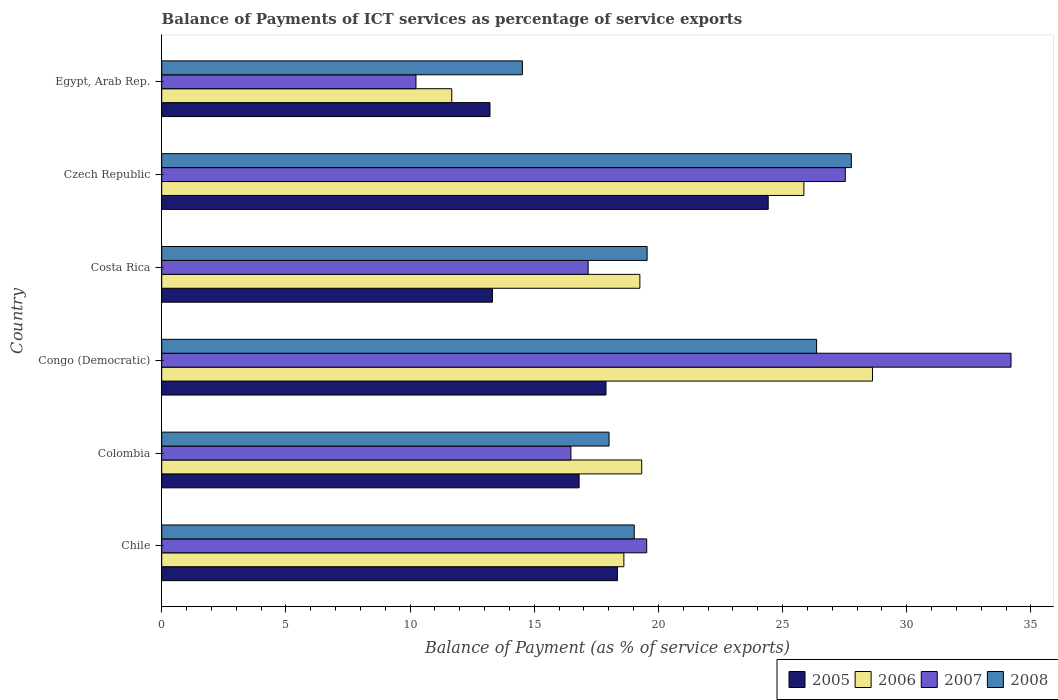How many groups of bars are there?
Keep it short and to the point. 6. Are the number of bars on each tick of the Y-axis equal?
Ensure brevity in your answer.  Yes. How many bars are there on the 6th tick from the bottom?
Provide a succinct answer. 4. What is the balance of payments of ICT services in 2007 in Egypt, Arab Rep.?
Your response must be concise. 10.24. Across all countries, what is the maximum balance of payments of ICT services in 2005?
Ensure brevity in your answer.  24.42. Across all countries, what is the minimum balance of payments of ICT services in 2006?
Offer a terse response. 11.68. In which country was the balance of payments of ICT services in 2006 maximum?
Offer a terse response. Congo (Democratic). In which country was the balance of payments of ICT services in 2007 minimum?
Your answer should be very brief. Egypt, Arab Rep. What is the total balance of payments of ICT services in 2007 in the graph?
Offer a very short reply. 125.14. What is the difference between the balance of payments of ICT services in 2006 in Congo (Democratic) and that in Egypt, Arab Rep.?
Your answer should be compact. 16.94. What is the difference between the balance of payments of ICT services in 2005 in Colombia and the balance of payments of ICT services in 2007 in Costa Rica?
Provide a succinct answer. -0.36. What is the average balance of payments of ICT services in 2006 per country?
Your answer should be very brief. 20.56. What is the difference between the balance of payments of ICT services in 2007 and balance of payments of ICT services in 2006 in Chile?
Provide a succinct answer. 0.92. In how many countries, is the balance of payments of ICT services in 2008 greater than 18 %?
Ensure brevity in your answer.  5. What is the ratio of the balance of payments of ICT services in 2008 in Chile to that in Congo (Democratic)?
Offer a terse response. 0.72. Is the difference between the balance of payments of ICT services in 2007 in Colombia and Egypt, Arab Rep. greater than the difference between the balance of payments of ICT services in 2006 in Colombia and Egypt, Arab Rep.?
Provide a short and direct response. No. What is the difference between the highest and the second highest balance of payments of ICT services in 2007?
Your response must be concise. 6.67. What is the difference between the highest and the lowest balance of payments of ICT services in 2006?
Your answer should be very brief. 16.94. In how many countries, is the balance of payments of ICT services in 2008 greater than the average balance of payments of ICT services in 2008 taken over all countries?
Make the answer very short. 2. What does the 3rd bar from the top in Czech Republic represents?
Provide a succinct answer. 2006. What does the 3rd bar from the bottom in Egypt, Arab Rep. represents?
Give a very brief answer. 2007. Are all the bars in the graph horizontal?
Offer a very short reply. Yes. How many countries are there in the graph?
Your answer should be very brief. 6. What is the difference between two consecutive major ticks on the X-axis?
Ensure brevity in your answer.  5. Are the values on the major ticks of X-axis written in scientific E-notation?
Give a very brief answer. No. Does the graph contain grids?
Ensure brevity in your answer.  No. How are the legend labels stacked?
Give a very brief answer. Horizontal. What is the title of the graph?
Ensure brevity in your answer.  Balance of Payments of ICT services as percentage of service exports. What is the label or title of the X-axis?
Your response must be concise. Balance of Payment (as % of service exports). What is the label or title of the Y-axis?
Your response must be concise. Country. What is the Balance of Payment (as % of service exports) of 2005 in Chile?
Give a very brief answer. 18.35. What is the Balance of Payment (as % of service exports) in 2006 in Chile?
Give a very brief answer. 18.61. What is the Balance of Payment (as % of service exports) of 2007 in Chile?
Make the answer very short. 19.53. What is the Balance of Payment (as % of service exports) of 2008 in Chile?
Your answer should be very brief. 19.03. What is the Balance of Payment (as % of service exports) of 2005 in Colombia?
Offer a terse response. 16.81. What is the Balance of Payment (as % of service exports) of 2006 in Colombia?
Offer a terse response. 19.33. What is the Balance of Payment (as % of service exports) of 2007 in Colombia?
Keep it short and to the point. 16.48. What is the Balance of Payment (as % of service exports) in 2008 in Colombia?
Give a very brief answer. 18.01. What is the Balance of Payment (as % of service exports) in 2005 in Congo (Democratic)?
Provide a short and direct response. 17.89. What is the Balance of Payment (as % of service exports) in 2006 in Congo (Democratic)?
Your answer should be very brief. 28.62. What is the Balance of Payment (as % of service exports) in 2007 in Congo (Democratic)?
Give a very brief answer. 34.2. What is the Balance of Payment (as % of service exports) of 2008 in Congo (Democratic)?
Provide a short and direct response. 26.37. What is the Balance of Payment (as % of service exports) in 2005 in Costa Rica?
Keep it short and to the point. 13.32. What is the Balance of Payment (as % of service exports) of 2006 in Costa Rica?
Make the answer very short. 19.25. What is the Balance of Payment (as % of service exports) in 2007 in Costa Rica?
Keep it short and to the point. 17.17. What is the Balance of Payment (as % of service exports) in 2008 in Costa Rica?
Offer a very short reply. 19.55. What is the Balance of Payment (as % of service exports) of 2005 in Czech Republic?
Offer a terse response. 24.42. What is the Balance of Payment (as % of service exports) of 2006 in Czech Republic?
Offer a terse response. 25.86. What is the Balance of Payment (as % of service exports) of 2007 in Czech Republic?
Offer a very short reply. 27.53. What is the Balance of Payment (as % of service exports) of 2008 in Czech Republic?
Your answer should be compact. 27.77. What is the Balance of Payment (as % of service exports) in 2005 in Egypt, Arab Rep.?
Provide a short and direct response. 13.22. What is the Balance of Payment (as % of service exports) of 2006 in Egypt, Arab Rep.?
Provide a short and direct response. 11.68. What is the Balance of Payment (as % of service exports) in 2007 in Egypt, Arab Rep.?
Provide a short and direct response. 10.24. What is the Balance of Payment (as % of service exports) of 2008 in Egypt, Arab Rep.?
Provide a succinct answer. 14.52. Across all countries, what is the maximum Balance of Payment (as % of service exports) in 2005?
Give a very brief answer. 24.42. Across all countries, what is the maximum Balance of Payment (as % of service exports) of 2006?
Make the answer very short. 28.62. Across all countries, what is the maximum Balance of Payment (as % of service exports) of 2007?
Make the answer very short. 34.2. Across all countries, what is the maximum Balance of Payment (as % of service exports) of 2008?
Your answer should be compact. 27.77. Across all countries, what is the minimum Balance of Payment (as % of service exports) of 2005?
Your answer should be compact. 13.22. Across all countries, what is the minimum Balance of Payment (as % of service exports) in 2006?
Provide a short and direct response. 11.68. Across all countries, what is the minimum Balance of Payment (as % of service exports) in 2007?
Provide a succinct answer. 10.24. Across all countries, what is the minimum Balance of Payment (as % of service exports) of 2008?
Offer a very short reply. 14.52. What is the total Balance of Payment (as % of service exports) in 2005 in the graph?
Offer a terse response. 104.01. What is the total Balance of Payment (as % of service exports) of 2006 in the graph?
Your answer should be compact. 123.35. What is the total Balance of Payment (as % of service exports) in 2007 in the graph?
Ensure brevity in your answer.  125.14. What is the total Balance of Payment (as % of service exports) in 2008 in the graph?
Keep it short and to the point. 125.25. What is the difference between the Balance of Payment (as % of service exports) in 2005 in Chile and that in Colombia?
Your answer should be very brief. 1.54. What is the difference between the Balance of Payment (as % of service exports) of 2006 in Chile and that in Colombia?
Your answer should be very brief. -0.72. What is the difference between the Balance of Payment (as % of service exports) of 2007 in Chile and that in Colombia?
Your answer should be compact. 3.05. What is the difference between the Balance of Payment (as % of service exports) in 2008 in Chile and that in Colombia?
Provide a short and direct response. 1.01. What is the difference between the Balance of Payment (as % of service exports) in 2005 in Chile and that in Congo (Democratic)?
Ensure brevity in your answer.  0.46. What is the difference between the Balance of Payment (as % of service exports) in 2006 in Chile and that in Congo (Democratic)?
Your response must be concise. -10.01. What is the difference between the Balance of Payment (as % of service exports) in 2007 in Chile and that in Congo (Democratic)?
Offer a terse response. -14.67. What is the difference between the Balance of Payment (as % of service exports) of 2008 in Chile and that in Congo (Democratic)?
Give a very brief answer. -7.34. What is the difference between the Balance of Payment (as % of service exports) in 2005 in Chile and that in Costa Rica?
Provide a short and direct response. 5.03. What is the difference between the Balance of Payment (as % of service exports) in 2006 in Chile and that in Costa Rica?
Your answer should be very brief. -0.64. What is the difference between the Balance of Payment (as % of service exports) in 2007 in Chile and that in Costa Rica?
Provide a succinct answer. 2.36. What is the difference between the Balance of Payment (as % of service exports) in 2008 in Chile and that in Costa Rica?
Your answer should be very brief. -0.52. What is the difference between the Balance of Payment (as % of service exports) in 2005 in Chile and that in Czech Republic?
Your response must be concise. -6.07. What is the difference between the Balance of Payment (as % of service exports) of 2006 in Chile and that in Czech Republic?
Your response must be concise. -7.25. What is the difference between the Balance of Payment (as % of service exports) of 2007 in Chile and that in Czech Republic?
Provide a succinct answer. -8. What is the difference between the Balance of Payment (as % of service exports) in 2008 in Chile and that in Czech Republic?
Keep it short and to the point. -8.74. What is the difference between the Balance of Payment (as % of service exports) in 2005 in Chile and that in Egypt, Arab Rep.?
Give a very brief answer. 5.13. What is the difference between the Balance of Payment (as % of service exports) in 2006 in Chile and that in Egypt, Arab Rep.?
Your answer should be very brief. 6.93. What is the difference between the Balance of Payment (as % of service exports) of 2007 in Chile and that in Egypt, Arab Rep.?
Offer a very short reply. 9.29. What is the difference between the Balance of Payment (as % of service exports) in 2008 in Chile and that in Egypt, Arab Rep.?
Keep it short and to the point. 4.5. What is the difference between the Balance of Payment (as % of service exports) of 2005 in Colombia and that in Congo (Democratic)?
Give a very brief answer. -1.08. What is the difference between the Balance of Payment (as % of service exports) in 2006 in Colombia and that in Congo (Democratic)?
Keep it short and to the point. -9.29. What is the difference between the Balance of Payment (as % of service exports) in 2007 in Colombia and that in Congo (Democratic)?
Provide a short and direct response. -17.72. What is the difference between the Balance of Payment (as % of service exports) of 2008 in Colombia and that in Congo (Democratic)?
Keep it short and to the point. -8.36. What is the difference between the Balance of Payment (as % of service exports) in 2005 in Colombia and that in Costa Rica?
Keep it short and to the point. 3.49. What is the difference between the Balance of Payment (as % of service exports) of 2006 in Colombia and that in Costa Rica?
Your response must be concise. 0.07. What is the difference between the Balance of Payment (as % of service exports) of 2007 in Colombia and that in Costa Rica?
Offer a terse response. -0.69. What is the difference between the Balance of Payment (as % of service exports) of 2008 in Colombia and that in Costa Rica?
Keep it short and to the point. -1.53. What is the difference between the Balance of Payment (as % of service exports) of 2005 in Colombia and that in Czech Republic?
Ensure brevity in your answer.  -7.61. What is the difference between the Balance of Payment (as % of service exports) of 2006 in Colombia and that in Czech Republic?
Your answer should be very brief. -6.53. What is the difference between the Balance of Payment (as % of service exports) in 2007 in Colombia and that in Czech Republic?
Offer a very short reply. -11.05. What is the difference between the Balance of Payment (as % of service exports) of 2008 in Colombia and that in Czech Republic?
Keep it short and to the point. -9.76. What is the difference between the Balance of Payment (as % of service exports) of 2005 in Colombia and that in Egypt, Arab Rep.?
Your answer should be very brief. 3.59. What is the difference between the Balance of Payment (as % of service exports) in 2006 in Colombia and that in Egypt, Arab Rep.?
Your answer should be compact. 7.65. What is the difference between the Balance of Payment (as % of service exports) of 2007 in Colombia and that in Egypt, Arab Rep.?
Ensure brevity in your answer.  6.24. What is the difference between the Balance of Payment (as % of service exports) of 2008 in Colombia and that in Egypt, Arab Rep.?
Provide a succinct answer. 3.49. What is the difference between the Balance of Payment (as % of service exports) of 2005 in Congo (Democratic) and that in Costa Rica?
Offer a terse response. 4.57. What is the difference between the Balance of Payment (as % of service exports) in 2006 in Congo (Democratic) and that in Costa Rica?
Provide a succinct answer. 9.37. What is the difference between the Balance of Payment (as % of service exports) in 2007 in Congo (Democratic) and that in Costa Rica?
Provide a succinct answer. 17.03. What is the difference between the Balance of Payment (as % of service exports) of 2008 in Congo (Democratic) and that in Costa Rica?
Make the answer very short. 6.82. What is the difference between the Balance of Payment (as % of service exports) of 2005 in Congo (Democratic) and that in Czech Republic?
Keep it short and to the point. -6.53. What is the difference between the Balance of Payment (as % of service exports) in 2006 in Congo (Democratic) and that in Czech Republic?
Provide a succinct answer. 2.76. What is the difference between the Balance of Payment (as % of service exports) in 2007 in Congo (Democratic) and that in Czech Republic?
Ensure brevity in your answer.  6.67. What is the difference between the Balance of Payment (as % of service exports) in 2008 in Congo (Democratic) and that in Czech Republic?
Offer a terse response. -1.4. What is the difference between the Balance of Payment (as % of service exports) in 2005 in Congo (Democratic) and that in Egypt, Arab Rep.?
Offer a terse response. 4.67. What is the difference between the Balance of Payment (as % of service exports) in 2006 in Congo (Democratic) and that in Egypt, Arab Rep.?
Your response must be concise. 16.94. What is the difference between the Balance of Payment (as % of service exports) of 2007 in Congo (Democratic) and that in Egypt, Arab Rep.?
Provide a short and direct response. 23.96. What is the difference between the Balance of Payment (as % of service exports) of 2008 in Congo (Democratic) and that in Egypt, Arab Rep.?
Make the answer very short. 11.85. What is the difference between the Balance of Payment (as % of service exports) of 2005 in Costa Rica and that in Czech Republic?
Ensure brevity in your answer.  -11.1. What is the difference between the Balance of Payment (as % of service exports) of 2006 in Costa Rica and that in Czech Republic?
Offer a terse response. -6.6. What is the difference between the Balance of Payment (as % of service exports) in 2007 in Costa Rica and that in Czech Republic?
Offer a terse response. -10.36. What is the difference between the Balance of Payment (as % of service exports) in 2008 in Costa Rica and that in Czech Republic?
Offer a terse response. -8.22. What is the difference between the Balance of Payment (as % of service exports) of 2005 in Costa Rica and that in Egypt, Arab Rep.?
Provide a succinct answer. 0.1. What is the difference between the Balance of Payment (as % of service exports) of 2006 in Costa Rica and that in Egypt, Arab Rep.?
Offer a terse response. 7.57. What is the difference between the Balance of Payment (as % of service exports) of 2007 in Costa Rica and that in Egypt, Arab Rep.?
Offer a very short reply. 6.93. What is the difference between the Balance of Payment (as % of service exports) in 2008 in Costa Rica and that in Egypt, Arab Rep.?
Offer a terse response. 5.02. What is the difference between the Balance of Payment (as % of service exports) in 2005 in Czech Republic and that in Egypt, Arab Rep.?
Your answer should be compact. 11.2. What is the difference between the Balance of Payment (as % of service exports) in 2006 in Czech Republic and that in Egypt, Arab Rep.?
Keep it short and to the point. 14.18. What is the difference between the Balance of Payment (as % of service exports) of 2007 in Czech Republic and that in Egypt, Arab Rep.?
Ensure brevity in your answer.  17.29. What is the difference between the Balance of Payment (as % of service exports) of 2008 in Czech Republic and that in Egypt, Arab Rep.?
Your response must be concise. 13.24. What is the difference between the Balance of Payment (as % of service exports) in 2005 in Chile and the Balance of Payment (as % of service exports) in 2006 in Colombia?
Offer a very short reply. -0.98. What is the difference between the Balance of Payment (as % of service exports) in 2005 in Chile and the Balance of Payment (as % of service exports) in 2007 in Colombia?
Keep it short and to the point. 1.87. What is the difference between the Balance of Payment (as % of service exports) of 2005 in Chile and the Balance of Payment (as % of service exports) of 2008 in Colombia?
Offer a very short reply. 0.34. What is the difference between the Balance of Payment (as % of service exports) in 2006 in Chile and the Balance of Payment (as % of service exports) in 2007 in Colombia?
Make the answer very short. 2.13. What is the difference between the Balance of Payment (as % of service exports) of 2006 in Chile and the Balance of Payment (as % of service exports) of 2008 in Colombia?
Provide a short and direct response. 0.6. What is the difference between the Balance of Payment (as % of service exports) of 2007 in Chile and the Balance of Payment (as % of service exports) of 2008 in Colombia?
Your answer should be very brief. 1.52. What is the difference between the Balance of Payment (as % of service exports) in 2005 in Chile and the Balance of Payment (as % of service exports) in 2006 in Congo (Democratic)?
Your answer should be very brief. -10.27. What is the difference between the Balance of Payment (as % of service exports) in 2005 in Chile and the Balance of Payment (as % of service exports) in 2007 in Congo (Democratic)?
Offer a very short reply. -15.85. What is the difference between the Balance of Payment (as % of service exports) in 2005 in Chile and the Balance of Payment (as % of service exports) in 2008 in Congo (Democratic)?
Provide a succinct answer. -8.02. What is the difference between the Balance of Payment (as % of service exports) of 2006 in Chile and the Balance of Payment (as % of service exports) of 2007 in Congo (Democratic)?
Keep it short and to the point. -15.59. What is the difference between the Balance of Payment (as % of service exports) in 2006 in Chile and the Balance of Payment (as % of service exports) in 2008 in Congo (Democratic)?
Your answer should be compact. -7.76. What is the difference between the Balance of Payment (as % of service exports) in 2007 in Chile and the Balance of Payment (as % of service exports) in 2008 in Congo (Democratic)?
Your answer should be compact. -6.84. What is the difference between the Balance of Payment (as % of service exports) of 2005 in Chile and the Balance of Payment (as % of service exports) of 2006 in Costa Rica?
Your answer should be very brief. -0.9. What is the difference between the Balance of Payment (as % of service exports) of 2005 in Chile and the Balance of Payment (as % of service exports) of 2007 in Costa Rica?
Make the answer very short. 1.18. What is the difference between the Balance of Payment (as % of service exports) of 2005 in Chile and the Balance of Payment (as % of service exports) of 2008 in Costa Rica?
Offer a very short reply. -1.2. What is the difference between the Balance of Payment (as % of service exports) in 2006 in Chile and the Balance of Payment (as % of service exports) in 2007 in Costa Rica?
Your answer should be compact. 1.44. What is the difference between the Balance of Payment (as % of service exports) of 2006 in Chile and the Balance of Payment (as % of service exports) of 2008 in Costa Rica?
Make the answer very short. -0.94. What is the difference between the Balance of Payment (as % of service exports) of 2007 in Chile and the Balance of Payment (as % of service exports) of 2008 in Costa Rica?
Ensure brevity in your answer.  -0.02. What is the difference between the Balance of Payment (as % of service exports) in 2005 in Chile and the Balance of Payment (as % of service exports) in 2006 in Czech Republic?
Offer a very short reply. -7.51. What is the difference between the Balance of Payment (as % of service exports) of 2005 in Chile and the Balance of Payment (as % of service exports) of 2007 in Czech Republic?
Make the answer very short. -9.18. What is the difference between the Balance of Payment (as % of service exports) in 2005 in Chile and the Balance of Payment (as % of service exports) in 2008 in Czech Republic?
Provide a short and direct response. -9.42. What is the difference between the Balance of Payment (as % of service exports) in 2006 in Chile and the Balance of Payment (as % of service exports) in 2007 in Czech Republic?
Provide a succinct answer. -8.92. What is the difference between the Balance of Payment (as % of service exports) in 2006 in Chile and the Balance of Payment (as % of service exports) in 2008 in Czech Republic?
Your response must be concise. -9.16. What is the difference between the Balance of Payment (as % of service exports) of 2007 in Chile and the Balance of Payment (as % of service exports) of 2008 in Czech Republic?
Keep it short and to the point. -8.24. What is the difference between the Balance of Payment (as % of service exports) of 2005 in Chile and the Balance of Payment (as % of service exports) of 2006 in Egypt, Arab Rep.?
Make the answer very short. 6.67. What is the difference between the Balance of Payment (as % of service exports) in 2005 in Chile and the Balance of Payment (as % of service exports) in 2007 in Egypt, Arab Rep.?
Provide a short and direct response. 8.11. What is the difference between the Balance of Payment (as % of service exports) in 2005 in Chile and the Balance of Payment (as % of service exports) in 2008 in Egypt, Arab Rep.?
Give a very brief answer. 3.83. What is the difference between the Balance of Payment (as % of service exports) in 2006 in Chile and the Balance of Payment (as % of service exports) in 2007 in Egypt, Arab Rep.?
Offer a very short reply. 8.37. What is the difference between the Balance of Payment (as % of service exports) in 2006 in Chile and the Balance of Payment (as % of service exports) in 2008 in Egypt, Arab Rep.?
Give a very brief answer. 4.09. What is the difference between the Balance of Payment (as % of service exports) in 2007 in Chile and the Balance of Payment (as % of service exports) in 2008 in Egypt, Arab Rep.?
Keep it short and to the point. 5.01. What is the difference between the Balance of Payment (as % of service exports) of 2005 in Colombia and the Balance of Payment (as % of service exports) of 2006 in Congo (Democratic)?
Your answer should be compact. -11.81. What is the difference between the Balance of Payment (as % of service exports) of 2005 in Colombia and the Balance of Payment (as % of service exports) of 2007 in Congo (Democratic)?
Give a very brief answer. -17.39. What is the difference between the Balance of Payment (as % of service exports) of 2005 in Colombia and the Balance of Payment (as % of service exports) of 2008 in Congo (Democratic)?
Your answer should be compact. -9.56. What is the difference between the Balance of Payment (as % of service exports) of 2006 in Colombia and the Balance of Payment (as % of service exports) of 2007 in Congo (Democratic)?
Ensure brevity in your answer.  -14.87. What is the difference between the Balance of Payment (as % of service exports) of 2006 in Colombia and the Balance of Payment (as % of service exports) of 2008 in Congo (Democratic)?
Offer a very short reply. -7.04. What is the difference between the Balance of Payment (as % of service exports) in 2007 in Colombia and the Balance of Payment (as % of service exports) in 2008 in Congo (Democratic)?
Offer a terse response. -9.89. What is the difference between the Balance of Payment (as % of service exports) of 2005 in Colombia and the Balance of Payment (as % of service exports) of 2006 in Costa Rica?
Your answer should be compact. -2.45. What is the difference between the Balance of Payment (as % of service exports) of 2005 in Colombia and the Balance of Payment (as % of service exports) of 2007 in Costa Rica?
Offer a terse response. -0.36. What is the difference between the Balance of Payment (as % of service exports) of 2005 in Colombia and the Balance of Payment (as % of service exports) of 2008 in Costa Rica?
Your response must be concise. -2.74. What is the difference between the Balance of Payment (as % of service exports) of 2006 in Colombia and the Balance of Payment (as % of service exports) of 2007 in Costa Rica?
Your answer should be very brief. 2.16. What is the difference between the Balance of Payment (as % of service exports) in 2006 in Colombia and the Balance of Payment (as % of service exports) in 2008 in Costa Rica?
Offer a terse response. -0.22. What is the difference between the Balance of Payment (as % of service exports) of 2007 in Colombia and the Balance of Payment (as % of service exports) of 2008 in Costa Rica?
Ensure brevity in your answer.  -3.07. What is the difference between the Balance of Payment (as % of service exports) of 2005 in Colombia and the Balance of Payment (as % of service exports) of 2006 in Czech Republic?
Your response must be concise. -9.05. What is the difference between the Balance of Payment (as % of service exports) in 2005 in Colombia and the Balance of Payment (as % of service exports) in 2007 in Czech Republic?
Provide a short and direct response. -10.72. What is the difference between the Balance of Payment (as % of service exports) of 2005 in Colombia and the Balance of Payment (as % of service exports) of 2008 in Czech Republic?
Offer a terse response. -10.96. What is the difference between the Balance of Payment (as % of service exports) of 2006 in Colombia and the Balance of Payment (as % of service exports) of 2007 in Czech Republic?
Ensure brevity in your answer.  -8.2. What is the difference between the Balance of Payment (as % of service exports) in 2006 in Colombia and the Balance of Payment (as % of service exports) in 2008 in Czech Republic?
Give a very brief answer. -8.44. What is the difference between the Balance of Payment (as % of service exports) in 2007 in Colombia and the Balance of Payment (as % of service exports) in 2008 in Czech Republic?
Offer a terse response. -11.29. What is the difference between the Balance of Payment (as % of service exports) of 2005 in Colombia and the Balance of Payment (as % of service exports) of 2006 in Egypt, Arab Rep.?
Your answer should be compact. 5.13. What is the difference between the Balance of Payment (as % of service exports) of 2005 in Colombia and the Balance of Payment (as % of service exports) of 2007 in Egypt, Arab Rep.?
Ensure brevity in your answer.  6.57. What is the difference between the Balance of Payment (as % of service exports) in 2005 in Colombia and the Balance of Payment (as % of service exports) in 2008 in Egypt, Arab Rep.?
Give a very brief answer. 2.28. What is the difference between the Balance of Payment (as % of service exports) in 2006 in Colombia and the Balance of Payment (as % of service exports) in 2007 in Egypt, Arab Rep.?
Your answer should be very brief. 9.09. What is the difference between the Balance of Payment (as % of service exports) of 2006 in Colombia and the Balance of Payment (as % of service exports) of 2008 in Egypt, Arab Rep.?
Provide a succinct answer. 4.8. What is the difference between the Balance of Payment (as % of service exports) of 2007 in Colombia and the Balance of Payment (as % of service exports) of 2008 in Egypt, Arab Rep.?
Offer a very short reply. 1.95. What is the difference between the Balance of Payment (as % of service exports) of 2005 in Congo (Democratic) and the Balance of Payment (as % of service exports) of 2006 in Costa Rica?
Provide a short and direct response. -1.36. What is the difference between the Balance of Payment (as % of service exports) of 2005 in Congo (Democratic) and the Balance of Payment (as % of service exports) of 2007 in Costa Rica?
Provide a succinct answer. 0.72. What is the difference between the Balance of Payment (as % of service exports) in 2005 in Congo (Democratic) and the Balance of Payment (as % of service exports) in 2008 in Costa Rica?
Your answer should be compact. -1.66. What is the difference between the Balance of Payment (as % of service exports) in 2006 in Congo (Democratic) and the Balance of Payment (as % of service exports) in 2007 in Costa Rica?
Give a very brief answer. 11.45. What is the difference between the Balance of Payment (as % of service exports) of 2006 in Congo (Democratic) and the Balance of Payment (as % of service exports) of 2008 in Costa Rica?
Ensure brevity in your answer.  9.07. What is the difference between the Balance of Payment (as % of service exports) in 2007 in Congo (Democratic) and the Balance of Payment (as % of service exports) in 2008 in Costa Rica?
Provide a short and direct response. 14.65. What is the difference between the Balance of Payment (as % of service exports) in 2005 in Congo (Democratic) and the Balance of Payment (as % of service exports) in 2006 in Czech Republic?
Your answer should be compact. -7.97. What is the difference between the Balance of Payment (as % of service exports) of 2005 in Congo (Democratic) and the Balance of Payment (as % of service exports) of 2007 in Czech Republic?
Your answer should be very brief. -9.64. What is the difference between the Balance of Payment (as % of service exports) of 2005 in Congo (Democratic) and the Balance of Payment (as % of service exports) of 2008 in Czech Republic?
Make the answer very short. -9.88. What is the difference between the Balance of Payment (as % of service exports) of 2006 in Congo (Democratic) and the Balance of Payment (as % of service exports) of 2007 in Czech Republic?
Provide a short and direct response. 1.09. What is the difference between the Balance of Payment (as % of service exports) of 2006 in Congo (Democratic) and the Balance of Payment (as % of service exports) of 2008 in Czech Republic?
Give a very brief answer. 0.85. What is the difference between the Balance of Payment (as % of service exports) of 2007 in Congo (Democratic) and the Balance of Payment (as % of service exports) of 2008 in Czech Republic?
Your response must be concise. 6.43. What is the difference between the Balance of Payment (as % of service exports) in 2005 in Congo (Democratic) and the Balance of Payment (as % of service exports) in 2006 in Egypt, Arab Rep.?
Your response must be concise. 6.21. What is the difference between the Balance of Payment (as % of service exports) in 2005 in Congo (Democratic) and the Balance of Payment (as % of service exports) in 2007 in Egypt, Arab Rep.?
Make the answer very short. 7.65. What is the difference between the Balance of Payment (as % of service exports) in 2005 in Congo (Democratic) and the Balance of Payment (as % of service exports) in 2008 in Egypt, Arab Rep.?
Your response must be concise. 3.37. What is the difference between the Balance of Payment (as % of service exports) in 2006 in Congo (Democratic) and the Balance of Payment (as % of service exports) in 2007 in Egypt, Arab Rep.?
Your answer should be compact. 18.38. What is the difference between the Balance of Payment (as % of service exports) of 2006 in Congo (Democratic) and the Balance of Payment (as % of service exports) of 2008 in Egypt, Arab Rep.?
Your answer should be very brief. 14.1. What is the difference between the Balance of Payment (as % of service exports) in 2007 in Congo (Democratic) and the Balance of Payment (as % of service exports) in 2008 in Egypt, Arab Rep.?
Offer a very short reply. 19.68. What is the difference between the Balance of Payment (as % of service exports) of 2005 in Costa Rica and the Balance of Payment (as % of service exports) of 2006 in Czech Republic?
Keep it short and to the point. -12.54. What is the difference between the Balance of Payment (as % of service exports) of 2005 in Costa Rica and the Balance of Payment (as % of service exports) of 2007 in Czech Republic?
Offer a terse response. -14.21. What is the difference between the Balance of Payment (as % of service exports) in 2005 in Costa Rica and the Balance of Payment (as % of service exports) in 2008 in Czech Republic?
Make the answer very short. -14.45. What is the difference between the Balance of Payment (as % of service exports) in 2006 in Costa Rica and the Balance of Payment (as % of service exports) in 2007 in Czech Republic?
Your answer should be very brief. -8.27. What is the difference between the Balance of Payment (as % of service exports) in 2006 in Costa Rica and the Balance of Payment (as % of service exports) in 2008 in Czech Republic?
Offer a terse response. -8.51. What is the difference between the Balance of Payment (as % of service exports) in 2007 in Costa Rica and the Balance of Payment (as % of service exports) in 2008 in Czech Republic?
Offer a terse response. -10.6. What is the difference between the Balance of Payment (as % of service exports) of 2005 in Costa Rica and the Balance of Payment (as % of service exports) of 2006 in Egypt, Arab Rep.?
Offer a terse response. 1.64. What is the difference between the Balance of Payment (as % of service exports) in 2005 in Costa Rica and the Balance of Payment (as % of service exports) in 2007 in Egypt, Arab Rep.?
Your answer should be very brief. 3.08. What is the difference between the Balance of Payment (as % of service exports) of 2005 in Costa Rica and the Balance of Payment (as % of service exports) of 2008 in Egypt, Arab Rep.?
Keep it short and to the point. -1.21. What is the difference between the Balance of Payment (as % of service exports) of 2006 in Costa Rica and the Balance of Payment (as % of service exports) of 2007 in Egypt, Arab Rep.?
Make the answer very short. 9.02. What is the difference between the Balance of Payment (as % of service exports) of 2006 in Costa Rica and the Balance of Payment (as % of service exports) of 2008 in Egypt, Arab Rep.?
Make the answer very short. 4.73. What is the difference between the Balance of Payment (as % of service exports) in 2007 in Costa Rica and the Balance of Payment (as % of service exports) in 2008 in Egypt, Arab Rep.?
Provide a succinct answer. 2.65. What is the difference between the Balance of Payment (as % of service exports) of 2005 in Czech Republic and the Balance of Payment (as % of service exports) of 2006 in Egypt, Arab Rep.?
Your answer should be very brief. 12.74. What is the difference between the Balance of Payment (as % of service exports) in 2005 in Czech Republic and the Balance of Payment (as % of service exports) in 2007 in Egypt, Arab Rep.?
Make the answer very short. 14.18. What is the difference between the Balance of Payment (as % of service exports) of 2005 in Czech Republic and the Balance of Payment (as % of service exports) of 2008 in Egypt, Arab Rep.?
Provide a short and direct response. 9.9. What is the difference between the Balance of Payment (as % of service exports) in 2006 in Czech Republic and the Balance of Payment (as % of service exports) in 2007 in Egypt, Arab Rep.?
Provide a succinct answer. 15.62. What is the difference between the Balance of Payment (as % of service exports) of 2006 in Czech Republic and the Balance of Payment (as % of service exports) of 2008 in Egypt, Arab Rep.?
Offer a terse response. 11.34. What is the difference between the Balance of Payment (as % of service exports) of 2007 in Czech Republic and the Balance of Payment (as % of service exports) of 2008 in Egypt, Arab Rep.?
Provide a succinct answer. 13. What is the average Balance of Payment (as % of service exports) of 2005 per country?
Your answer should be compact. 17.33. What is the average Balance of Payment (as % of service exports) in 2006 per country?
Offer a very short reply. 20.56. What is the average Balance of Payment (as % of service exports) in 2007 per country?
Make the answer very short. 20.86. What is the average Balance of Payment (as % of service exports) of 2008 per country?
Give a very brief answer. 20.88. What is the difference between the Balance of Payment (as % of service exports) of 2005 and Balance of Payment (as % of service exports) of 2006 in Chile?
Make the answer very short. -0.26. What is the difference between the Balance of Payment (as % of service exports) in 2005 and Balance of Payment (as % of service exports) in 2007 in Chile?
Offer a very short reply. -1.18. What is the difference between the Balance of Payment (as % of service exports) of 2005 and Balance of Payment (as % of service exports) of 2008 in Chile?
Your response must be concise. -0.68. What is the difference between the Balance of Payment (as % of service exports) of 2006 and Balance of Payment (as % of service exports) of 2007 in Chile?
Provide a succinct answer. -0.92. What is the difference between the Balance of Payment (as % of service exports) in 2006 and Balance of Payment (as % of service exports) in 2008 in Chile?
Ensure brevity in your answer.  -0.42. What is the difference between the Balance of Payment (as % of service exports) in 2007 and Balance of Payment (as % of service exports) in 2008 in Chile?
Provide a succinct answer. 0.5. What is the difference between the Balance of Payment (as % of service exports) in 2005 and Balance of Payment (as % of service exports) in 2006 in Colombia?
Provide a short and direct response. -2.52. What is the difference between the Balance of Payment (as % of service exports) of 2005 and Balance of Payment (as % of service exports) of 2007 in Colombia?
Your answer should be very brief. 0.33. What is the difference between the Balance of Payment (as % of service exports) of 2005 and Balance of Payment (as % of service exports) of 2008 in Colombia?
Provide a succinct answer. -1.21. What is the difference between the Balance of Payment (as % of service exports) of 2006 and Balance of Payment (as % of service exports) of 2007 in Colombia?
Your answer should be compact. 2.85. What is the difference between the Balance of Payment (as % of service exports) of 2006 and Balance of Payment (as % of service exports) of 2008 in Colombia?
Provide a succinct answer. 1.32. What is the difference between the Balance of Payment (as % of service exports) of 2007 and Balance of Payment (as % of service exports) of 2008 in Colombia?
Offer a very short reply. -1.54. What is the difference between the Balance of Payment (as % of service exports) in 2005 and Balance of Payment (as % of service exports) in 2006 in Congo (Democratic)?
Offer a very short reply. -10.73. What is the difference between the Balance of Payment (as % of service exports) of 2005 and Balance of Payment (as % of service exports) of 2007 in Congo (Democratic)?
Offer a very short reply. -16.31. What is the difference between the Balance of Payment (as % of service exports) of 2005 and Balance of Payment (as % of service exports) of 2008 in Congo (Democratic)?
Provide a succinct answer. -8.48. What is the difference between the Balance of Payment (as % of service exports) of 2006 and Balance of Payment (as % of service exports) of 2007 in Congo (Democratic)?
Provide a succinct answer. -5.58. What is the difference between the Balance of Payment (as % of service exports) of 2006 and Balance of Payment (as % of service exports) of 2008 in Congo (Democratic)?
Your answer should be compact. 2.25. What is the difference between the Balance of Payment (as % of service exports) of 2007 and Balance of Payment (as % of service exports) of 2008 in Congo (Democratic)?
Your answer should be compact. 7.83. What is the difference between the Balance of Payment (as % of service exports) in 2005 and Balance of Payment (as % of service exports) in 2006 in Costa Rica?
Make the answer very short. -5.94. What is the difference between the Balance of Payment (as % of service exports) in 2005 and Balance of Payment (as % of service exports) in 2007 in Costa Rica?
Your answer should be compact. -3.85. What is the difference between the Balance of Payment (as % of service exports) of 2005 and Balance of Payment (as % of service exports) of 2008 in Costa Rica?
Provide a succinct answer. -6.23. What is the difference between the Balance of Payment (as % of service exports) of 2006 and Balance of Payment (as % of service exports) of 2007 in Costa Rica?
Give a very brief answer. 2.08. What is the difference between the Balance of Payment (as % of service exports) in 2006 and Balance of Payment (as % of service exports) in 2008 in Costa Rica?
Your response must be concise. -0.29. What is the difference between the Balance of Payment (as % of service exports) in 2007 and Balance of Payment (as % of service exports) in 2008 in Costa Rica?
Your answer should be very brief. -2.38. What is the difference between the Balance of Payment (as % of service exports) in 2005 and Balance of Payment (as % of service exports) in 2006 in Czech Republic?
Your answer should be very brief. -1.44. What is the difference between the Balance of Payment (as % of service exports) in 2005 and Balance of Payment (as % of service exports) in 2007 in Czech Republic?
Your response must be concise. -3.1. What is the difference between the Balance of Payment (as % of service exports) in 2005 and Balance of Payment (as % of service exports) in 2008 in Czech Republic?
Give a very brief answer. -3.35. What is the difference between the Balance of Payment (as % of service exports) of 2006 and Balance of Payment (as % of service exports) of 2007 in Czech Republic?
Offer a very short reply. -1.67. What is the difference between the Balance of Payment (as % of service exports) in 2006 and Balance of Payment (as % of service exports) in 2008 in Czech Republic?
Your response must be concise. -1.91. What is the difference between the Balance of Payment (as % of service exports) of 2007 and Balance of Payment (as % of service exports) of 2008 in Czech Republic?
Ensure brevity in your answer.  -0.24. What is the difference between the Balance of Payment (as % of service exports) in 2005 and Balance of Payment (as % of service exports) in 2006 in Egypt, Arab Rep.?
Make the answer very short. 1.54. What is the difference between the Balance of Payment (as % of service exports) of 2005 and Balance of Payment (as % of service exports) of 2007 in Egypt, Arab Rep.?
Keep it short and to the point. 2.98. What is the difference between the Balance of Payment (as % of service exports) of 2005 and Balance of Payment (as % of service exports) of 2008 in Egypt, Arab Rep.?
Offer a very short reply. -1.3. What is the difference between the Balance of Payment (as % of service exports) of 2006 and Balance of Payment (as % of service exports) of 2007 in Egypt, Arab Rep.?
Offer a terse response. 1.44. What is the difference between the Balance of Payment (as % of service exports) of 2006 and Balance of Payment (as % of service exports) of 2008 in Egypt, Arab Rep.?
Offer a very short reply. -2.84. What is the difference between the Balance of Payment (as % of service exports) of 2007 and Balance of Payment (as % of service exports) of 2008 in Egypt, Arab Rep.?
Offer a very short reply. -4.29. What is the ratio of the Balance of Payment (as % of service exports) in 2005 in Chile to that in Colombia?
Make the answer very short. 1.09. What is the ratio of the Balance of Payment (as % of service exports) in 2006 in Chile to that in Colombia?
Your response must be concise. 0.96. What is the ratio of the Balance of Payment (as % of service exports) in 2007 in Chile to that in Colombia?
Your response must be concise. 1.19. What is the ratio of the Balance of Payment (as % of service exports) in 2008 in Chile to that in Colombia?
Provide a succinct answer. 1.06. What is the ratio of the Balance of Payment (as % of service exports) of 2005 in Chile to that in Congo (Democratic)?
Your response must be concise. 1.03. What is the ratio of the Balance of Payment (as % of service exports) in 2006 in Chile to that in Congo (Democratic)?
Keep it short and to the point. 0.65. What is the ratio of the Balance of Payment (as % of service exports) in 2007 in Chile to that in Congo (Democratic)?
Your answer should be very brief. 0.57. What is the ratio of the Balance of Payment (as % of service exports) in 2008 in Chile to that in Congo (Democratic)?
Your response must be concise. 0.72. What is the ratio of the Balance of Payment (as % of service exports) in 2005 in Chile to that in Costa Rica?
Your answer should be compact. 1.38. What is the ratio of the Balance of Payment (as % of service exports) of 2006 in Chile to that in Costa Rica?
Ensure brevity in your answer.  0.97. What is the ratio of the Balance of Payment (as % of service exports) of 2007 in Chile to that in Costa Rica?
Offer a terse response. 1.14. What is the ratio of the Balance of Payment (as % of service exports) of 2008 in Chile to that in Costa Rica?
Give a very brief answer. 0.97. What is the ratio of the Balance of Payment (as % of service exports) of 2005 in Chile to that in Czech Republic?
Ensure brevity in your answer.  0.75. What is the ratio of the Balance of Payment (as % of service exports) of 2006 in Chile to that in Czech Republic?
Ensure brevity in your answer.  0.72. What is the ratio of the Balance of Payment (as % of service exports) in 2007 in Chile to that in Czech Republic?
Make the answer very short. 0.71. What is the ratio of the Balance of Payment (as % of service exports) of 2008 in Chile to that in Czech Republic?
Your answer should be compact. 0.69. What is the ratio of the Balance of Payment (as % of service exports) in 2005 in Chile to that in Egypt, Arab Rep.?
Give a very brief answer. 1.39. What is the ratio of the Balance of Payment (as % of service exports) of 2006 in Chile to that in Egypt, Arab Rep.?
Provide a short and direct response. 1.59. What is the ratio of the Balance of Payment (as % of service exports) in 2007 in Chile to that in Egypt, Arab Rep.?
Keep it short and to the point. 1.91. What is the ratio of the Balance of Payment (as % of service exports) of 2008 in Chile to that in Egypt, Arab Rep.?
Make the answer very short. 1.31. What is the ratio of the Balance of Payment (as % of service exports) of 2005 in Colombia to that in Congo (Democratic)?
Offer a terse response. 0.94. What is the ratio of the Balance of Payment (as % of service exports) in 2006 in Colombia to that in Congo (Democratic)?
Provide a succinct answer. 0.68. What is the ratio of the Balance of Payment (as % of service exports) of 2007 in Colombia to that in Congo (Democratic)?
Your answer should be compact. 0.48. What is the ratio of the Balance of Payment (as % of service exports) in 2008 in Colombia to that in Congo (Democratic)?
Provide a short and direct response. 0.68. What is the ratio of the Balance of Payment (as % of service exports) of 2005 in Colombia to that in Costa Rica?
Ensure brevity in your answer.  1.26. What is the ratio of the Balance of Payment (as % of service exports) of 2006 in Colombia to that in Costa Rica?
Your answer should be very brief. 1. What is the ratio of the Balance of Payment (as % of service exports) of 2007 in Colombia to that in Costa Rica?
Your response must be concise. 0.96. What is the ratio of the Balance of Payment (as % of service exports) in 2008 in Colombia to that in Costa Rica?
Make the answer very short. 0.92. What is the ratio of the Balance of Payment (as % of service exports) of 2005 in Colombia to that in Czech Republic?
Your response must be concise. 0.69. What is the ratio of the Balance of Payment (as % of service exports) in 2006 in Colombia to that in Czech Republic?
Your response must be concise. 0.75. What is the ratio of the Balance of Payment (as % of service exports) in 2007 in Colombia to that in Czech Republic?
Keep it short and to the point. 0.6. What is the ratio of the Balance of Payment (as % of service exports) in 2008 in Colombia to that in Czech Republic?
Offer a very short reply. 0.65. What is the ratio of the Balance of Payment (as % of service exports) of 2005 in Colombia to that in Egypt, Arab Rep.?
Offer a very short reply. 1.27. What is the ratio of the Balance of Payment (as % of service exports) in 2006 in Colombia to that in Egypt, Arab Rep.?
Your answer should be very brief. 1.65. What is the ratio of the Balance of Payment (as % of service exports) of 2007 in Colombia to that in Egypt, Arab Rep.?
Ensure brevity in your answer.  1.61. What is the ratio of the Balance of Payment (as % of service exports) in 2008 in Colombia to that in Egypt, Arab Rep.?
Your answer should be very brief. 1.24. What is the ratio of the Balance of Payment (as % of service exports) of 2005 in Congo (Democratic) to that in Costa Rica?
Offer a terse response. 1.34. What is the ratio of the Balance of Payment (as % of service exports) of 2006 in Congo (Democratic) to that in Costa Rica?
Provide a succinct answer. 1.49. What is the ratio of the Balance of Payment (as % of service exports) in 2007 in Congo (Democratic) to that in Costa Rica?
Provide a succinct answer. 1.99. What is the ratio of the Balance of Payment (as % of service exports) of 2008 in Congo (Democratic) to that in Costa Rica?
Your answer should be very brief. 1.35. What is the ratio of the Balance of Payment (as % of service exports) of 2005 in Congo (Democratic) to that in Czech Republic?
Provide a short and direct response. 0.73. What is the ratio of the Balance of Payment (as % of service exports) in 2006 in Congo (Democratic) to that in Czech Republic?
Your answer should be compact. 1.11. What is the ratio of the Balance of Payment (as % of service exports) in 2007 in Congo (Democratic) to that in Czech Republic?
Your answer should be very brief. 1.24. What is the ratio of the Balance of Payment (as % of service exports) of 2008 in Congo (Democratic) to that in Czech Republic?
Your response must be concise. 0.95. What is the ratio of the Balance of Payment (as % of service exports) in 2005 in Congo (Democratic) to that in Egypt, Arab Rep.?
Your answer should be very brief. 1.35. What is the ratio of the Balance of Payment (as % of service exports) of 2006 in Congo (Democratic) to that in Egypt, Arab Rep.?
Your response must be concise. 2.45. What is the ratio of the Balance of Payment (as % of service exports) of 2007 in Congo (Democratic) to that in Egypt, Arab Rep.?
Offer a terse response. 3.34. What is the ratio of the Balance of Payment (as % of service exports) of 2008 in Congo (Democratic) to that in Egypt, Arab Rep.?
Make the answer very short. 1.82. What is the ratio of the Balance of Payment (as % of service exports) of 2005 in Costa Rica to that in Czech Republic?
Offer a terse response. 0.55. What is the ratio of the Balance of Payment (as % of service exports) in 2006 in Costa Rica to that in Czech Republic?
Provide a short and direct response. 0.74. What is the ratio of the Balance of Payment (as % of service exports) in 2007 in Costa Rica to that in Czech Republic?
Provide a short and direct response. 0.62. What is the ratio of the Balance of Payment (as % of service exports) in 2008 in Costa Rica to that in Czech Republic?
Your answer should be very brief. 0.7. What is the ratio of the Balance of Payment (as % of service exports) of 2005 in Costa Rica to that in Egypt, Arab Rep.?
Ensure brevity in your answer.  1.01. What is the ratio of the Balance of Payment (as % of service exports) in 2006 in Costa Rica to that in Egypt, Arab Rep.?
Offer a terse response. 1.65. What is the ratio of the Balance of Payment (as % of service exports) in 2007 in Costa Rica to that in Egypt, Arab Rep.?
Provide a succinct answer. 1.68. What is the ratio of the Balance of Payment (as % of service exports) in 2008 in Costa Rica to that in Egypt, Arab Rep.?
Keep it short and to the point. 1.35. What is the ratio of the Balance of Payment (as % of service exports) in 2005 in Czech Republic to that in Egypt, Arab Rep.?
Offer a terse response. 1.85. What is the ratio of the Balance of Payment (as % of service exports) of 2006 in Czech Republic to that in Egypt, Arab Rep.?
Ensure brevity in your answer.  2.21. What is the ratio of the Balance of Payment (as % of service exports) of 2007 in Czech Republic to that in Egypt, Arab Rep.?
Offer a terse response. 2.69. What is the ratio of the Balance of Payment (as % of service exports) of 2008 in Czech Republic to that in Egypt, Arab Rep.?
Offer a very short reply. 1.91. What is the difference between the highest and the second highest Balance of Payment (as % of service exports) in 2005?
Provide a short and direct response. 6.07. What is the difference between the highest and the second highest Balance of Payment (as % of service exports) of 2006?
Make the answer very short. 2.76. What is the difference between the highest and the second highest Balance of Payment (as % of service exports) of 2007?
Your answer should be very brief. 6.67. What is the difference between the highest and the second highest Balance of Payment (as % of service exports) of 2008?
Your response must be concise. 1.4. What is the difference between the highest and the lowest Balance of Payment (as % of service exports) in 2005?
Give a very brief answer. 11.2. What is the difference between the highest and the lowest Balance of Payment (as % of service exports) in 2006?
Ensure brevity in your answer.  16.94. What is the difference between the highest and the lowest Balance of Payment (as % of service exports) of 2007?
Offer a terse response. 23.96. What is the difference between the highest and the lowest Balance of Payment (as % of service exports) in 2008?
Your answer should be very brief. 13.24. 